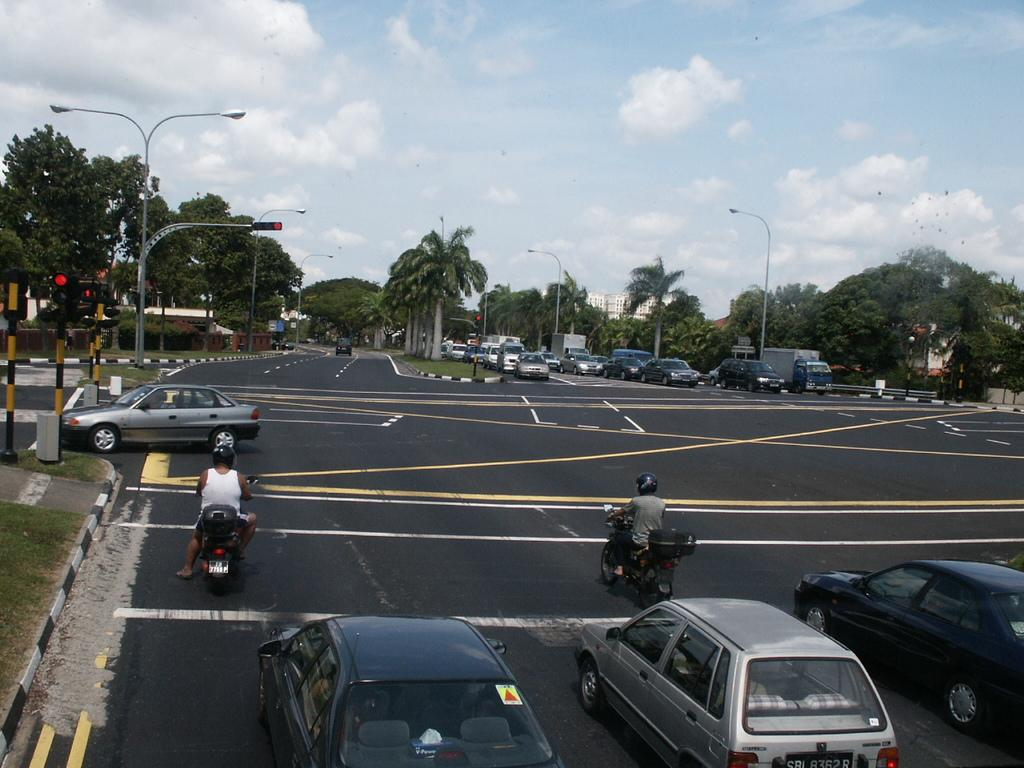What is the perspective of the image? The image shows a top view of a road. What is happening with the cars on the road? There are cars waiting at a signal on the road. What type of vegetation can be seen in the image? There are coconut trees visible in the image. What is the traffic situation on the road? There is a traffic jam with cars present in the image. Can you see any writers working on their novels in the image? There are no writers or novels present in the image; it shows a top view of a road with cars and coconut trees. 